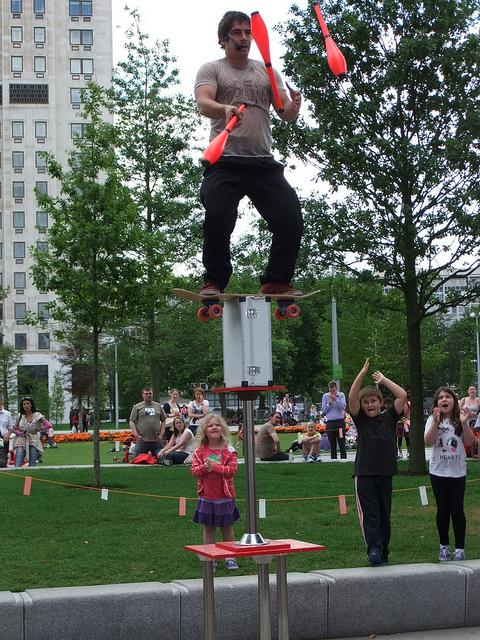How many pins are juggled up on top of the post by the man standing on the skateboard? Please explain your reasoning. three. There are three pins the guy is juggling. 